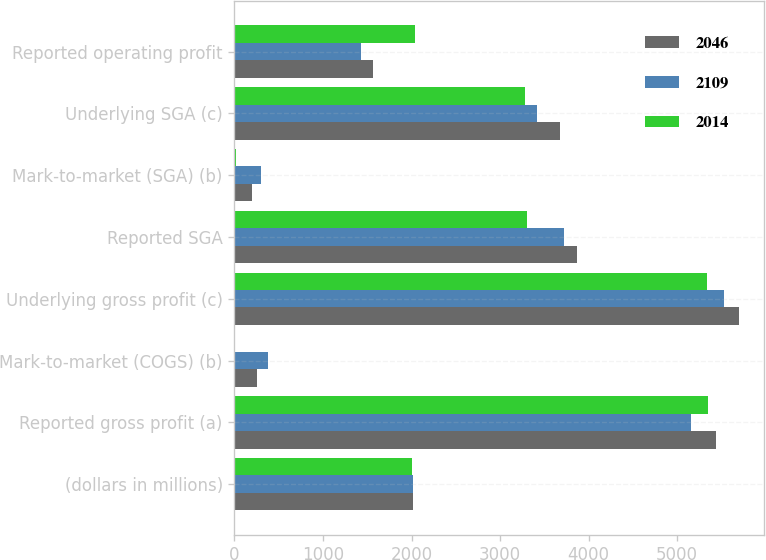Convert chart to OTSL. <chart><loc_0><loc_0><loc_500><loc_500><stacked_bar_chart><ecel><fcel>(dollars in millions)<fcel>Reported gross profit (a)<fcel>Mark-to-market (COGS) (b)<fcel>Underlying gross profit (c)<fcel>Reported SGA<fcel>Mark-to-market (SGA) (b)<fcel>Underlying SGA (c)<fcel>Reported operating profit<nl><fcel>2046<fcel>2012<fcel>5434<fcel>259<fcel>5693<fcel>3872<fcel>193<fcel>3679<fcel>1562<nl><fcel>2109<fcel>2011<fcel>5152<fcel>377<fcel>5529<fcel>3725<fcel>305<fcel>3420<fcel>1427<nl><fcel>2014<fcel>2010<fcel>5342<fcel>11<fcel>5331<fcel>3305<fcel>20<fcel>3285<fcel>2037<nl></chart> 